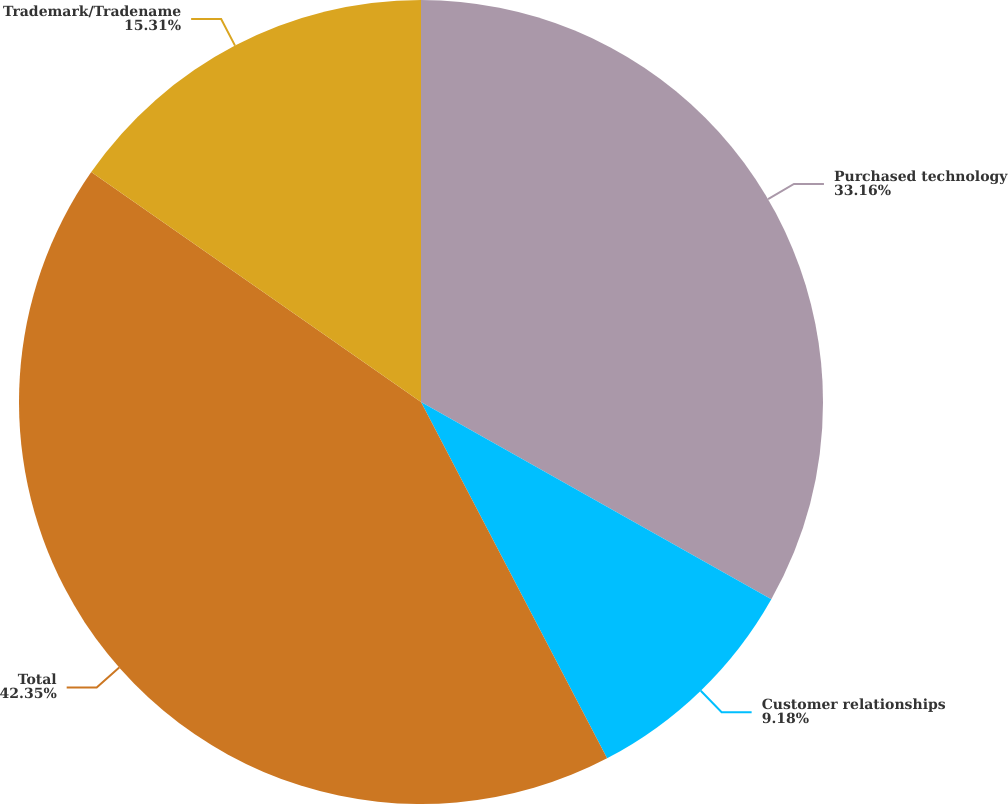Convert chart to OTSL. <chart><loc_0><loc_0><loc_500><loc_500><pie_chart><fcel>Purchased technology<fcel>Customer relationships<fcel>Total<fcel>Trademark/Tradename<nl><fcel>33.16%<fcel>9.18%<fcel>42.35%<fcel>15.31%<nl></chart> 